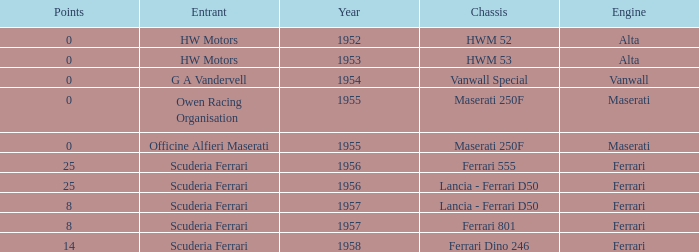Can you parse all the data within this table? {'header': ['Points', 'Entrant', 'Year', 'Chassis', 'Engine'], 'rows': [['0', 'HW Motors', '1952', 'HWM 52', 'Alta'], ['0', 'HW Motors', '1953', 'HWM 53', 'Alta'], ['0', 'G A Vandervell', '1954', 'Vanwall Special', 'Vanwall'], ['0', 'Owen Racing Organisation', '1955', 'Maserati 250F', 'Maserati'], ['0', 'Officine Alfieri Maserati', '1955', 'Maserati 250F', 'Maserati'], ['25', 'Scuderia Ferrari', '1956', 'Ferrari 555', 'Ferrari'], ['25', 'Scuderia Ferrari', '1956', 'Lancia - Ferrari D50', 'Ferrari'], ['8', 'Scuderia Ferrari', '1957', 'Lancia - Ferrari D50', 'Ferrari'], ['8', 'Scuderia Ferrari', '1957', 'Ferrari 801', 'Ferrari'], ['14', 'Scuderia Ferrari', '1958', 'Ferrari Dino 246', 'Ferrari']]} What is the entrant earlier than 1956 with a Vanwall Special chassis? G A Vandervell. 